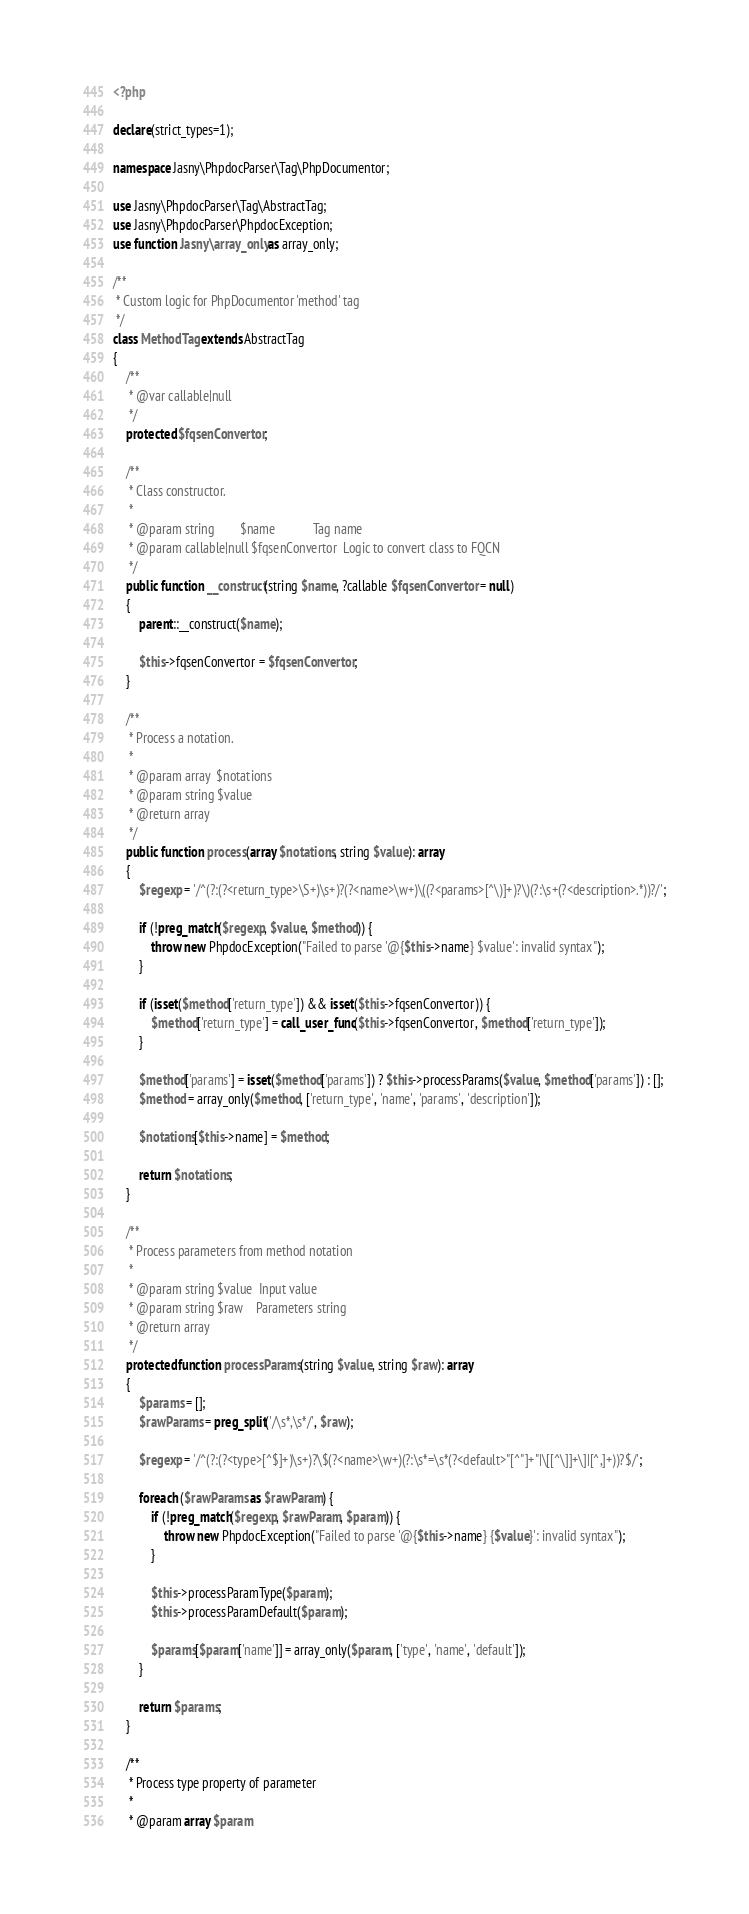<code> <loc_0><loc_0><loc_500><loc_500><_PHP_><?php

declare(strict_types=1);

namespace Jasny\PhpdocParser\Tag\PhpDocumentor;

use Jasny\PhpdocParser\Tag\AbstractTag;
use Jasny\PhpdocParser\PhpdocException;
use function Jasny\array_only as array_only;

/**
 * Custom logic for PhpDocumentor 'method' tag
 */
class MethodTag extends AbstractTag
{
    /**
     * @var callable|null
     */
    protected $fqsenConvertor;

    /**
     * Class constructor.
     *
     * @param string        $name            Tag name
     * @param callable|null $fqsenConvertor  Logic to convert class to FQCN
     */
    public function __construct(string $name, ?callable $fqsenConvertor = null)
    {
        parent::__construct($name);

        $this->fqsenConvertor = $fqsenConvertor;
    }

    /**
     * Process a notation.
     *
     * @param array  $notations
     * @param string $value
     * @return array
     */
    public function process(array $notations, string $value): array
    {
        $regexp = '/^(?:(?<return_type>\S+)\s+)?(?<name>\w+)\((?<params>[^\)]+)?\)(?:\s+(?<description>.*))?/';

        if (!preg_match($regexp, $value, $method)) {
            throw new PhpdocException("Failed to parse '@{$this->name} $value': invalid syntax");
        }

        if (isset($method['return_type']) && isset($this->fqsenConvertor)) {
            $method['return_type'] = call_user_func($this->fqsenConvertor, $method['return_type']);
        }

        $method['params'] = isset($method['params']) ? $this->processParams($value, $method['params']) : [];
        $method = array_only($method, ['return_type', 'name', 'params', 'description']);

        $notations[$this->name] = $method;

        return $notations;
    }

    /**
     * Process parameters from method notation
     *
     * @param string $value  Input value
     * @param string $raw    Parameters string
     * @return array
     */
    protected function processParams(string $value, string $raw): array
    {
        $params = [];
        $rawParams = preg_split('/\s*,\s*/', $raw);

        $regexp = '/^(?:(?<type>[^$]+)\s+)?\$(?<name>\w+)(?:\s*=\s*(?<default>"[^"]+"|\[[^\]]+\]|[^,]+))?$/';

        foreach ($rawParams as $rawParam) {
            if (!preg_match($regexp, $rawParam, $param)) {
                throw new PhpdocException("Failed to parse '@{$this->name} {$value}': invalid syntax");
            }

            $this->processParamType($param);
            $this->processParamDefault($param);

            $params[$param['name']] = array_only($param, ['type', 'name', 'default']);
        }

        return $params;
    }

    /**
     * Process type property of parameter
     *
     * @param array $param</code> 